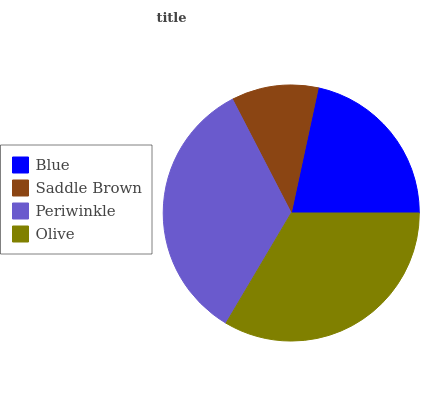Is Saddle Brown the minimum?
Answer yes or no. Yes. Is Periwinkle the maximum?
Answer yes or no. Yes. Is Periwinkle the minimum?
Answer yes or no. No. Is Saddle Brown the maximum?
Answer yes or no. No. Is Periwinkle greater than Saddle Brown?
Answer yes or no. Yes. Is Saddle Brown less than Periwinkle?
Answer yes or no. Yes. Is Saddle Brown greater than Periwinkle?
Answer yes or no. No. Is Periwinkle less than Saddle Brown?
Answer yes or no. No. Is Olive the high median?
Answer yes or no. Yes. Is Blue the low median?
Answer yes or no. Yes. Is Periwinkle the high median?
Answer yes or no. No. Is Periwinkle the low median?
Answer yes or no. No. 